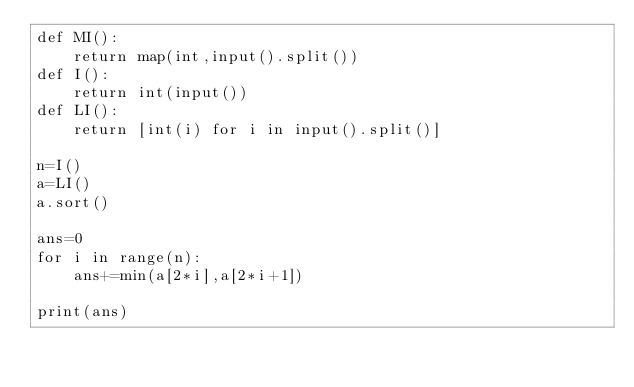<code> <loc_0><loc_0><loc_500><loc_500><_Python_>def MI():
    return map(int,input().split())
def I():
    return int(input())
def LI():
    return [int(i) for i in input().split()]
    
n=I()
a=LI()
a.sort()

ans=0
for i in range(n):
    ans+=min(a[2*i],a[2*i+1])

print(ans)</code> 